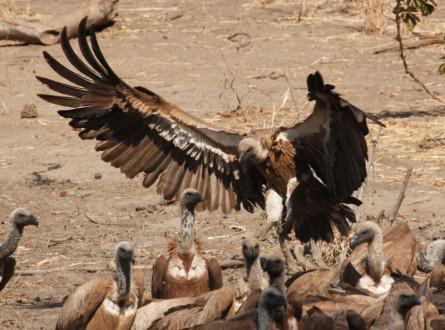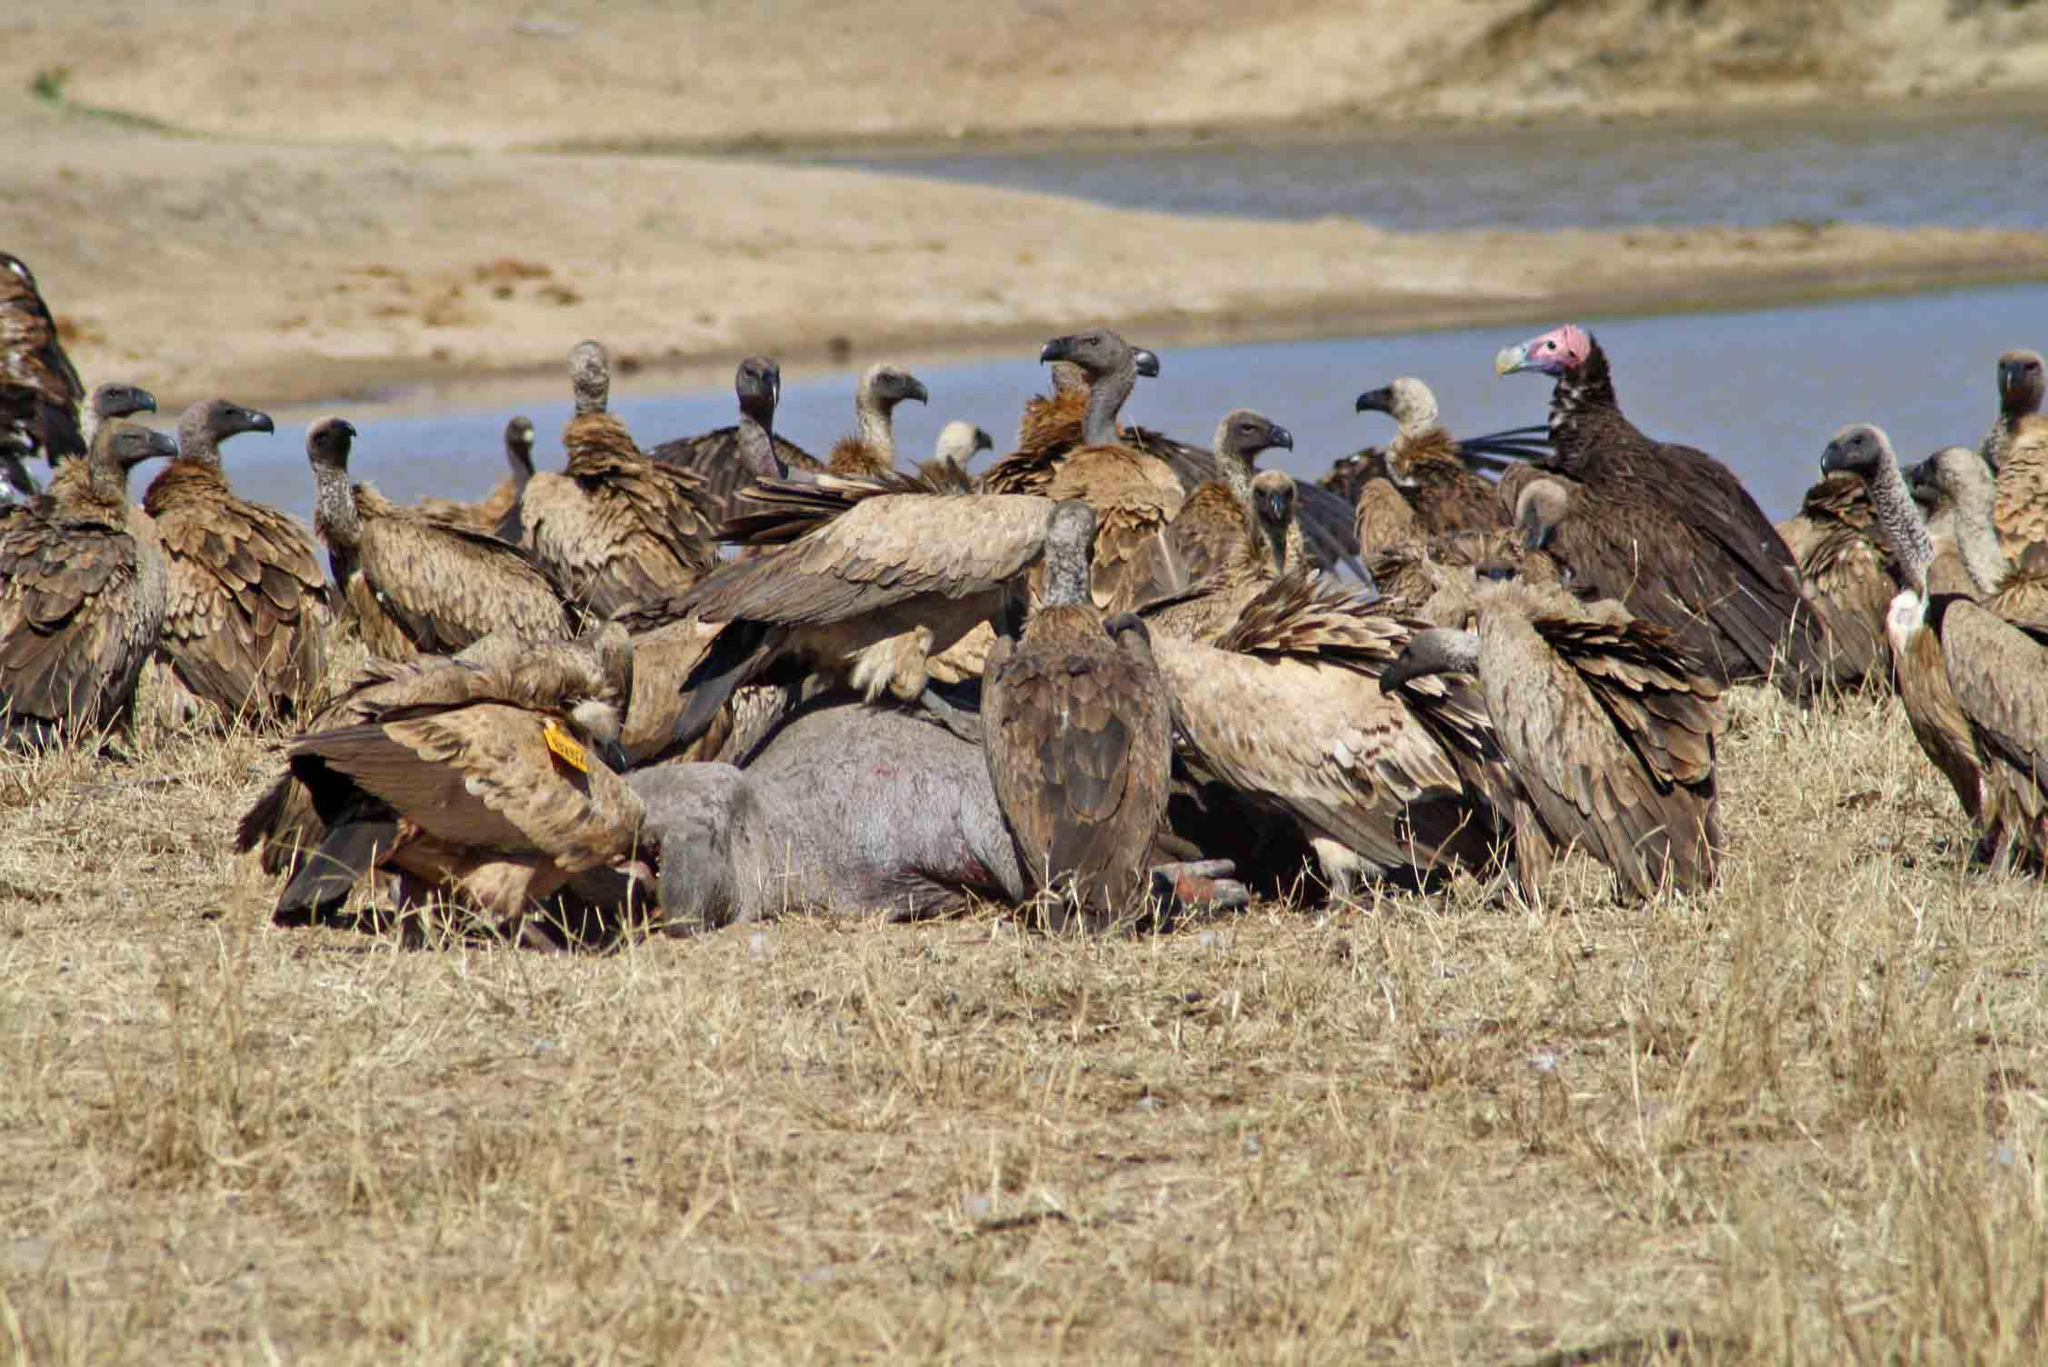The first image is the image on the left, the second image is the image on the right. Analyze the images presented: Is the assertion "At least one of the birds has its wings spread." valid? Answer yes or no. Yes. The first image is the image on the left, the second image is the image on the right. Assess this claim about the two images: "An image contains exactly two vultures, neither with spread wings.". Correct or not? Answer yes or no. No. 